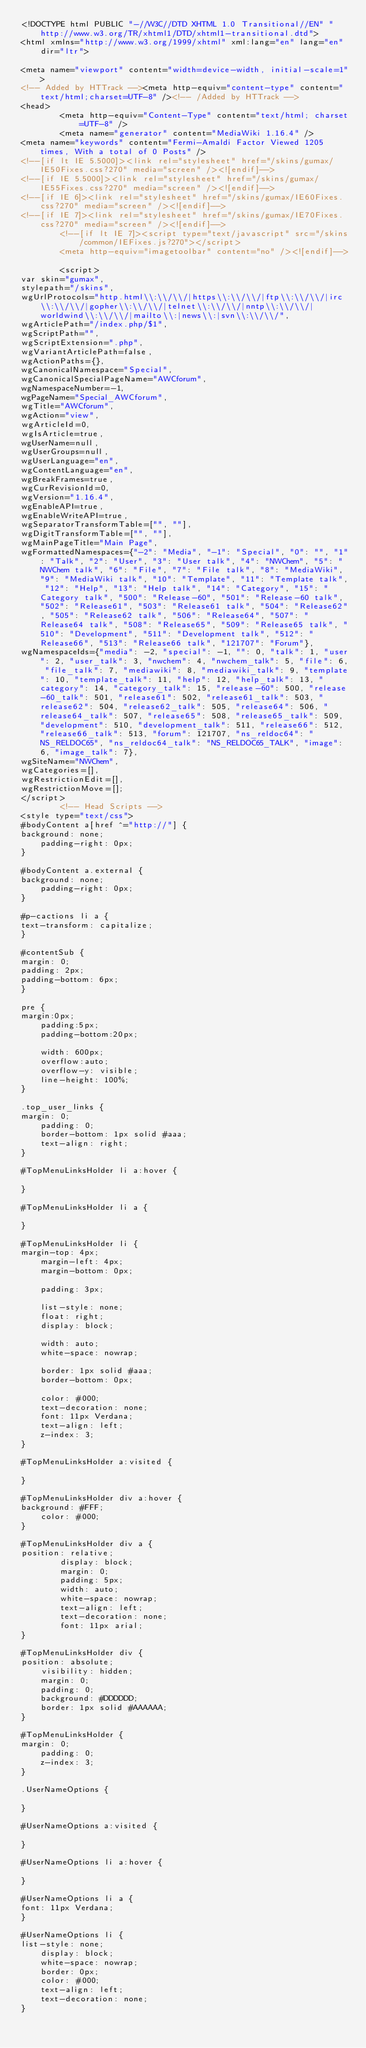<code> <loc_0><loc_0><loc_500><loc_500><_HTML_><!DOCTYPE html PUBLIC "-//W3C//DTD XHTML 1.0 Transitional//EN" "http://www.w3.org/TR/xhtml1/DTD/xhtml1-transitional.dtd">
<html xmlns="http://www.w3.org/1999/xhtml" xml:lang="en" lang="en" dir="ltr">
	
<meta name="viewport" content="width=device-width, initial-scale=1">
<!-- Added by HTTrack --><meta http-equiv="content-type" content="text/html;charset=UTF-8" /><!-- /Added by HTTrack -->
<head>
		<meta http-equiv="Content-Type" content="text/html; charset=UTF-8" />
		<meta name="generator" content="MediaWiki 1.16.4" />
<meta name="keywords" content="Fermi-Amaldi Factor Viewed 1205 times, With a total of 0 Posts" />
<!--[if lt IE 5.5000]><link rel="stylesheet" href="/skins/gumax/IE50Fixes.css?270" media="screen" /><![endif]-->
<!--[if IE 5.5000]><link rel="stylesheet" href="/skins/gumax/IE55Fixes.css?270" media="screen" /><![endif]-->
<!--[if IE 6]><link rel="stylesheet" href="/skins/gumax/IE60Fixes.css?270" media="screen" /><![endif]-->
<!--[if IE 7]><link rel="stylesheet" href="/skins/gumax/IE70Fixes.css?270" media="screen" /><![endif]-->
		<!--[if lt IE 7]><script type="text/javascript" src="/skins/common/IEFixes.js?270"></script>
		<meta http-equiv="imagetoolbar" content="no" /><![endif]-->

		<script>
var skin="gumax",
stylepath="/skins",
wgUrlProtocols="http.html\\:\\/\\/|https\\:\\/\\/|ftp\\:\\/\\/|irc\\:\\/\\/|gopher\\:\\/\\/|telnet\\:\\/\\/|nntp\\:\\/\\/|worldwind\\:\\/\\/|mailto\\:|news\\:|svn\\:\\/\\/",
wgArticlePath="/index.php/$1",
wgScriptPath="",
wgScriptExtension=".php",
wgVariantArticlePath=false,
wgActionPaths={},
wgCanonicalNamespace="Special",
wgCanonicalSpecialPageName="AWCforum",
wgNamespaceNumber=-1,
wgPageName="Special_AWCforum",
wgTitle="AWCforum",
wgAction="view",
wgArticleId=0,
wgIsArticle=true,
wgUserName=null,
wgUserGroups=null,
wgUserLanguage="en",
wgContentLanguage="en",
wgBreakFrames=true,
wgCurRevisionId=0,
wgVersion="1.16.4",
wgEnableAPI=true,
wgEnableWriteAPI=true,
wgSeparatorTransformTable=["", ""],
wgDigitTransformTable=["", ""],
wgMainPageTitle="Main Page",
wgFormattedNamespaces={"-2": "Media", "-1": "Special", "0": "", "1": "Talk", "2": "User", "3": "User talk", "4": "NWChem", "5": "NWChem talk", "6": "File", "7": "File talk", "8": "MediaWiki", "9": "MediaWiki talk", "10": "Template", "11": "Template talk", "12": "Help", "13": "Help talk", "14": "Category", "15": "Category talk", "500": "Release-60", "501": "Release-60 talk", "502": "Release61", "503": "Release61 talk", "504": "Release62", "505": "Release62 talk", "506": "Release64", "507": "Release64 talk", "508": "Release65", "509": "Release65 talk", "510": "Development", "511": "Development talk", "512": "Release66", "513": "Release66 talk", "121707": "Forum"},
wgNamespaceIds={"media": -2, "special": -1, "": 0, "talk": 1, "user": 2, "user_talk": 3, "nwchem": 4, "nwchem_talk": 5, "file": 6, "file_talk": 7, "mediawiki": 8, "mediawiki_talk": 9, "template": 10, "template_talk": 11, "help": 12, "help_talk": 13, "category": 14, "category_talk": 15, "release-60": 500, "release-60_talk": 501, "release61": 502, "release61_talk": 503, "release62": 504, "release62_talk": 505, "release64": 506, "release64_talk": 507, "release65": 508, "release65_talk": 509, "development": 510, "development_talk": 511, "release66": 512, "release66_talk": 513, "forum": 121707, "ns_reldoc64": "NS_RELDOC65", "ns_reldoc64_talk": "NS_RELDOC65_TALK", "image": 6, "image_talk": 7},
wgSiteName="NWChem",
wgCategories=[],
wgRestrictionEdit=[],
wgRestrictionMove=[];
</script>
		<!-- Head Scripts -->
<style type="text/css">
#bodyContent a[href ^="http://"] {
background: none;
    padding-right: 0px;
}

#bodyContent a.external {
background: none;
	padding-right: 0px;
}

#p-cactions li a {
text-transform: capitalize;
}

#contentSub {
margin: 0;
padding: 2px;
padding-bottom: 6px;
}

pre {
margin:0px; 
    padding:5px;
    padding-bottom:20px;  
    
    width: 600px;
    overflow:auto;
    overflow-y: visible;
    line-height: 100%;
}

.top_user_links {
margin: 0;
    padding: 0;
    border-bottom: 1px solid #aaa;
    text-align: right;
}

#TopMenuLinksHolder li a:hover {

}

#TopMenuLinksHolder li a {

}

#TopMenuLinksHolder li {
margin-top: 4px;   
    margin-left: 4px;
    margin-bottom: 0px;
    
    padding: 3px;
    
    list-style: none;
    float: right;
    display: block;
    
    width: auto;
    white-space: nowrap;
    
    border: 1px solid #aaa;
    border-bottom: 0px;
    
    color: #000;
    text-decoration: none;
    font: 11px Verdana;
    text-align: left;
    z-index: 3;
}

#TopMenuLinksHolder a:visited {

}

#TopMenuLinksHolder div a:hover {
background: #FFF;
    color: #000;
}

#TopMenuLinksHolder div a {
position: relative;
        display: block;
        margin: 0;
        padding: 5px;
        width: auto;
        white-space: nowrap;
        text-align: left;
        text-decoration: none;
        font: 11px arial;
}

#TopMenuLinksHolder div {
position: absolute;
    visibility: hidden;
    margin: 0;
    padding: 0;
    background: #DDDDDD;
    border: 1px solid #AAAAAA;
}

#TopMenuLinksHolder {
margin: 0;
    padding: 0;
    z-index: 3;
}

.UserNameOptions {

}

#UserNameOptions a:visited {

}

#UserNameOptions li a:hover {

}

#UserNameOptions li a {
font: 11px Verdana;
}

#UserNameOptions li {
list-style: none;
    display: block;
    white-space: nowrap;
    border: 0px;
    color: #000;
    text-align: left;
    text-decoration: none;
}
</code> 